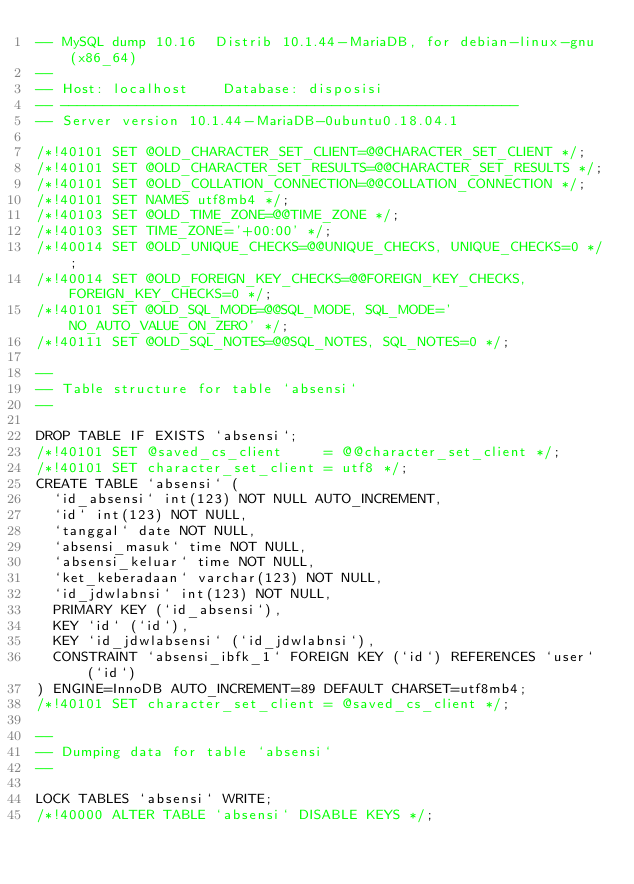<code> <loc_0><loc_0><loc_500><loc_500><_SQL_>-- MySQL dump 10.16  Distrib 10.1.44-MariaDB, for debian-linux-gnu (x86_64)
--
-- Host: localhost    Database: disposisi
-- ------------------------------------------------------
-- Server version	10.1.44-MariaDB-0ubuntu0.18.04.1

/*!40101 SET @OLD_CHARACTER_SET_CLIENT=@@CHARACTER_SET_CLIENT */;
/*!40101 SET @OLD_CHARACTER_SET_RESULTS=@@CHARACTER_SET_RESULTS */;
/*!40101 SET @OLD_COLLATION_CONNECTION=@@COLLATION_CONNECTION */;
/*!40101 SET NAMES utf8mb4 */;
/*!40103 SET @OLD_TIME_ZONE=@@TIME_ZONE */;
/*!40103 SET TIME_ZONE='+00:00' */;
/*!40014 SET @OLD_UNIQUE_CHECKS=@@UNIQUE_CHECKS, UNIQUE_CHECKS=0 */;
/*!40014 SET @OLD_FOREIGN_KEY_CHECKS=@@FOREIGN_KEY_CHECKS, FOREIGN_KEY_CHECKS=0 */;
/*!40101 SET @OLD_SQL_MODE=@@SQL_MODE, SQL_MODE='NO_AUTO_VALUE_ON_ZERO' */;
/*!40111 SET @OLD_SQL_NOTES=@@SQL_NOTES, SQL_NOTES=0 */;

--
-- Table structure for table `absensi`
--

DROP TABLE IF EXISTS `absensi`;
/*!40101 SET @saved_cs_client     = @@character_set_client */;
/*!40101 SET character_set_client = utf8 */;
CREATE TABLE `absensi` (
  `id_absensi` int(123) NOT NULL AUTO_INCREMENT,
  `id` int(123) NOT NULL,
  `tanggal` date NOT NULL,
  `absensi_masuk` time NOT NULL,
  `absensi_keluar` time NOT NULL,
  `ket_keberadaan` varchar(123) NOT NULL,
  `id_jdwlabnsi` int(123) NOT NULL,
  PRIMARY KEY (`id_absensi`),
  KEY `id` (`id`),
  KEY `id_jdwlabsensi` (`id_jdwlabnsi`),
  CONSTRAINT `absensi_ibfk_1` FOREIGN KEY (`id`) REFERENCES `user` (`id`)
) ENGINE=InnoDB AUTO_INCREMENT=89 DEFAULT CHARSET=utf8mb4;
/*!40101 SET character_set_client = @saved_cs_client */;

--
-- Dumping data for table `absensi`
--

LOCK TABLES `absensi` WRITE;
/*!40000 ALTER TABLE `absensi` DISABLE KEYS */;</code> 